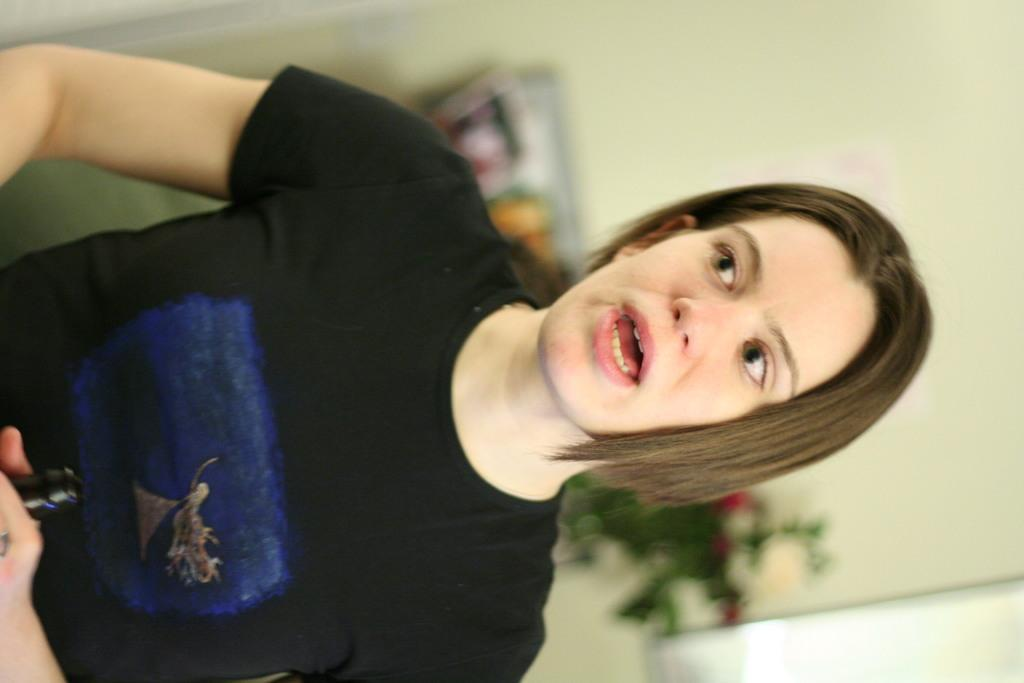What can be seen in the image? There is a person in the image. What is the person wearing? The person is wearing a black t-shirt. What is the person holding in their hand? The person is holding an object in their hand. Can you describe the background of the image? The background of the image is blurred. What type of punishment is the person receiving in the image? There is no indication of punishment in the image; the person is simply holding an object in their hand. 